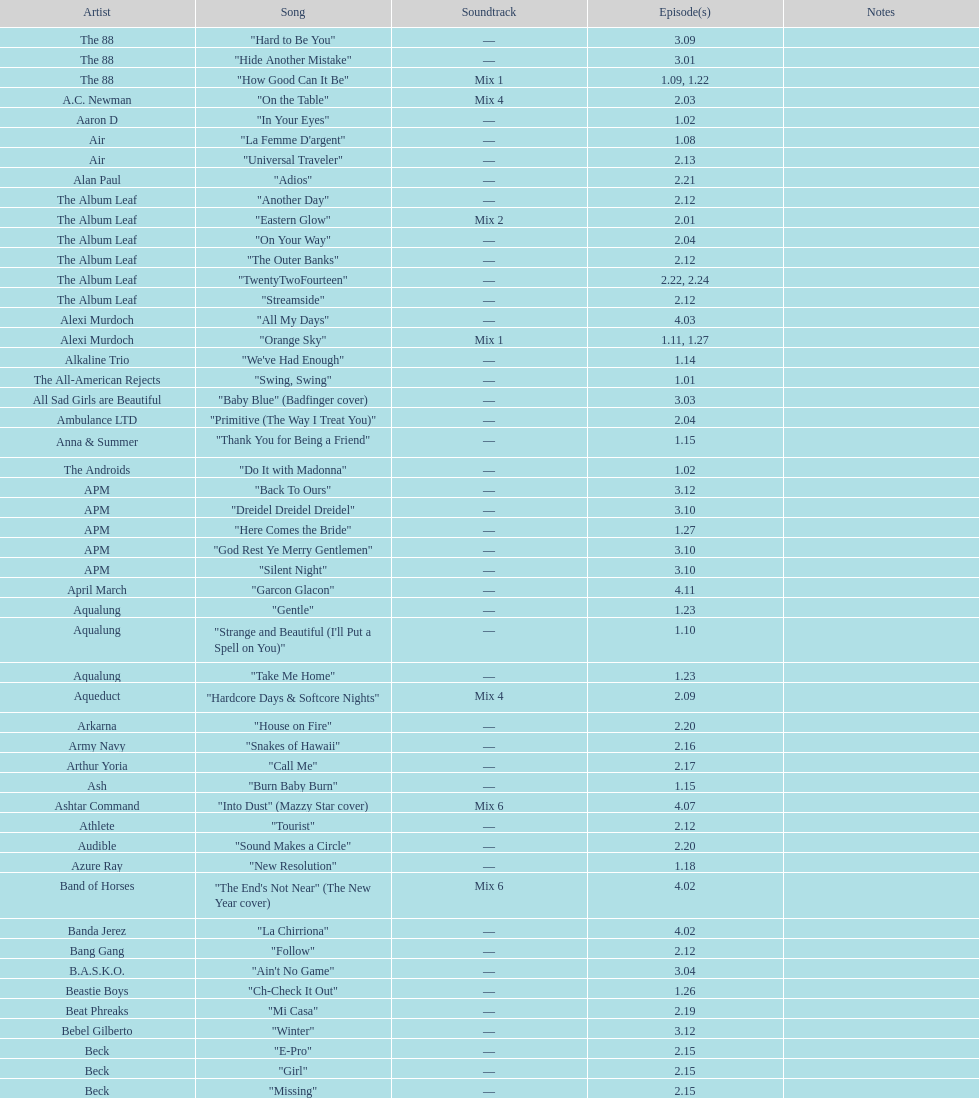"girl" and "el pro" were executed by which performer? Beck. 